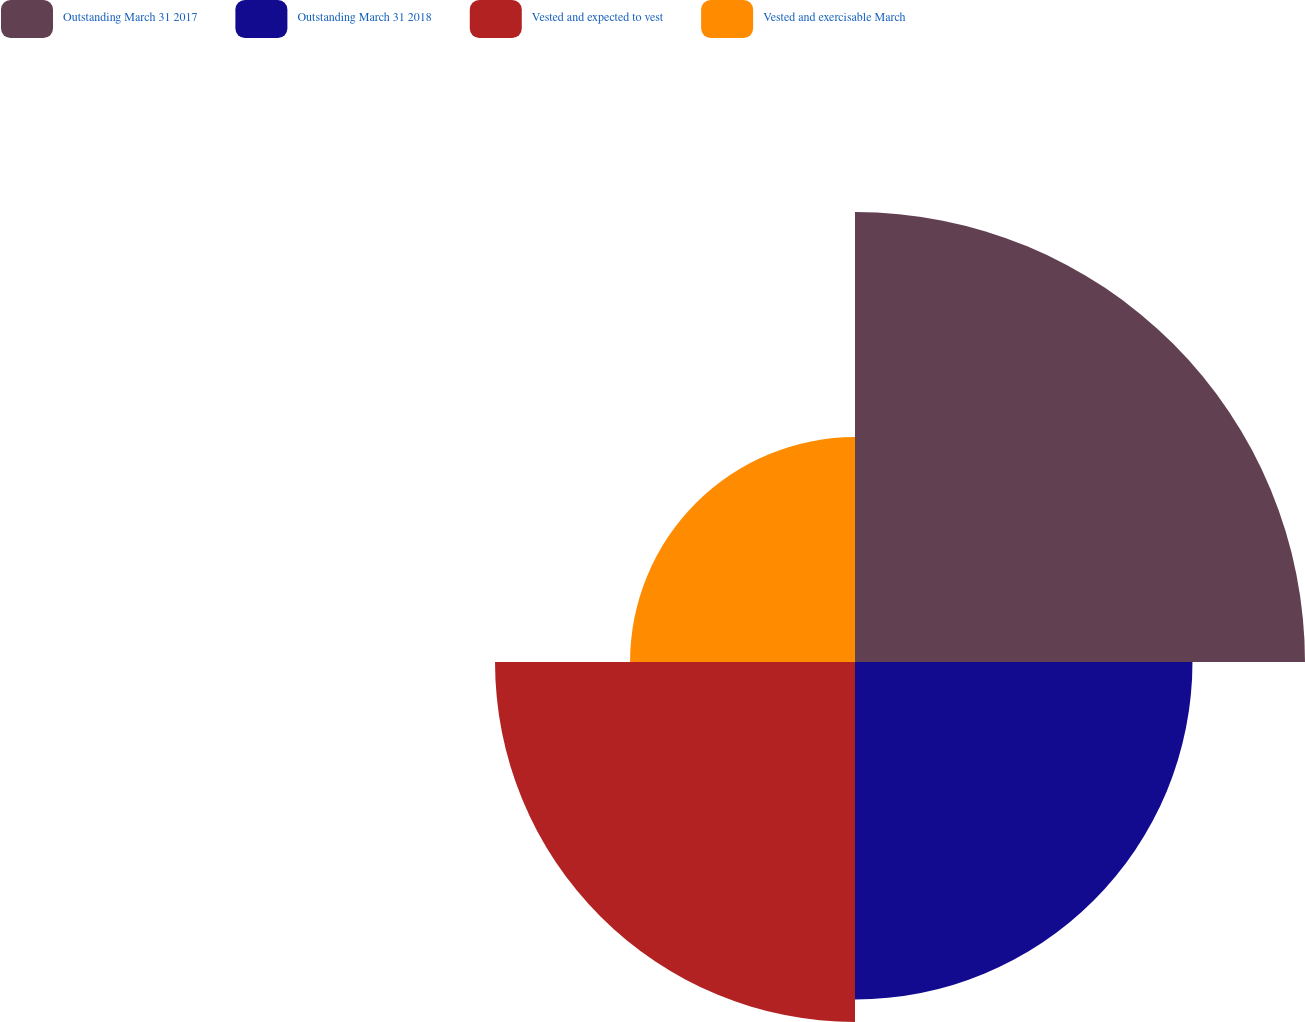Convert chart. <chart><loc_0><loc_0><loc_500><loc_500><pie_chart><fcel>Outstanding March 31 2017<fcel>Outstanding March 31 2018<fcel>Vested and expected to vest<fcel>Vested and exercisable March<nl><fcel>32.79%<fcel>24.59%<fcel>26.23%<fcel>16.39%<nl></chart> 